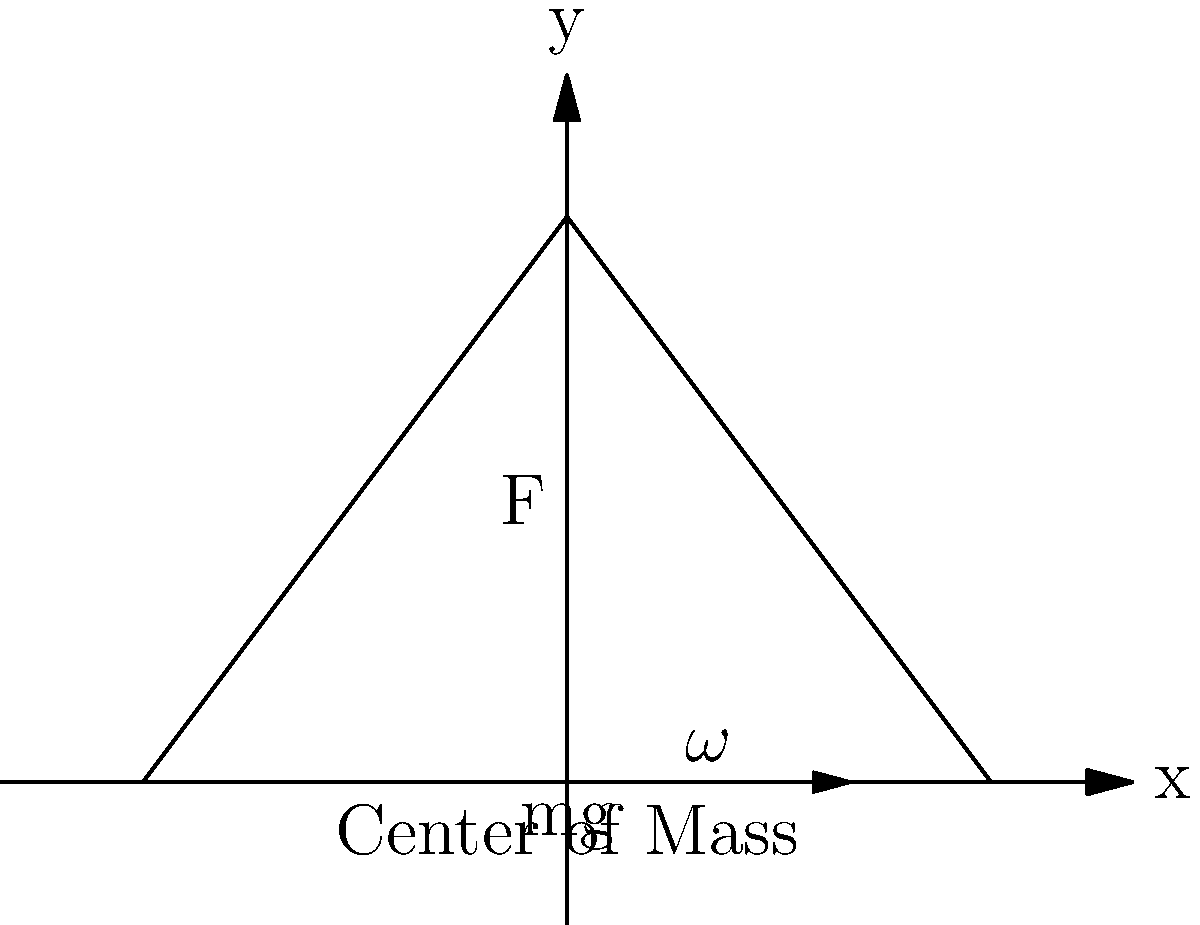In your school's upcoming stage play, you're designing a rotating triangular set piece. The triangle ABC has a base of 6 meters and a height of 4 meters. If the set piece rotates around its center of mass (located at the centroid) with an angular velocity $\omega$, what is the magnitude of the centripetal force acting on point C, given that the mass of the entire set piece is 50 kg and $\omega = 0.5$ rad/s? Let's approach this step-by-step:

1) First, we need to find the distance from the center of mass (centroid) to point C. In a triangle, the centroid is located 2/3 of the way from any vertex to the midpoint of the opposite side.

2) The height of the triangle is 4 meters, so the distance from C to the centroid is:
   $r = \frac{2}{3} \cdot 4 = \frac{8}{3}$ meters

3) The formula for centripetal force is:
   $F_c = m r \omega^2$

4) We're given:
   $m = 50$ kg (mass of the entire set piece)
   $r = \frac{8}{3}$ meters (distance from C to centroid)
   $\omega = 0.5$ rad/s (angular velocity)

5) Substituting these values into the formula:
   $F_c = 50 \cdot \frac{8}{3} \cdot (0.5)^2$

6) Simplifying:
   $F_c = 50 \cdot \frac{8}{3} \cdot 0.25 = \frac{100}{3} = 33.33$ N

Therefore, the magnitude of the centripetal force acting on point C is approximately 33.33 N.
Answer: 33.33 N 